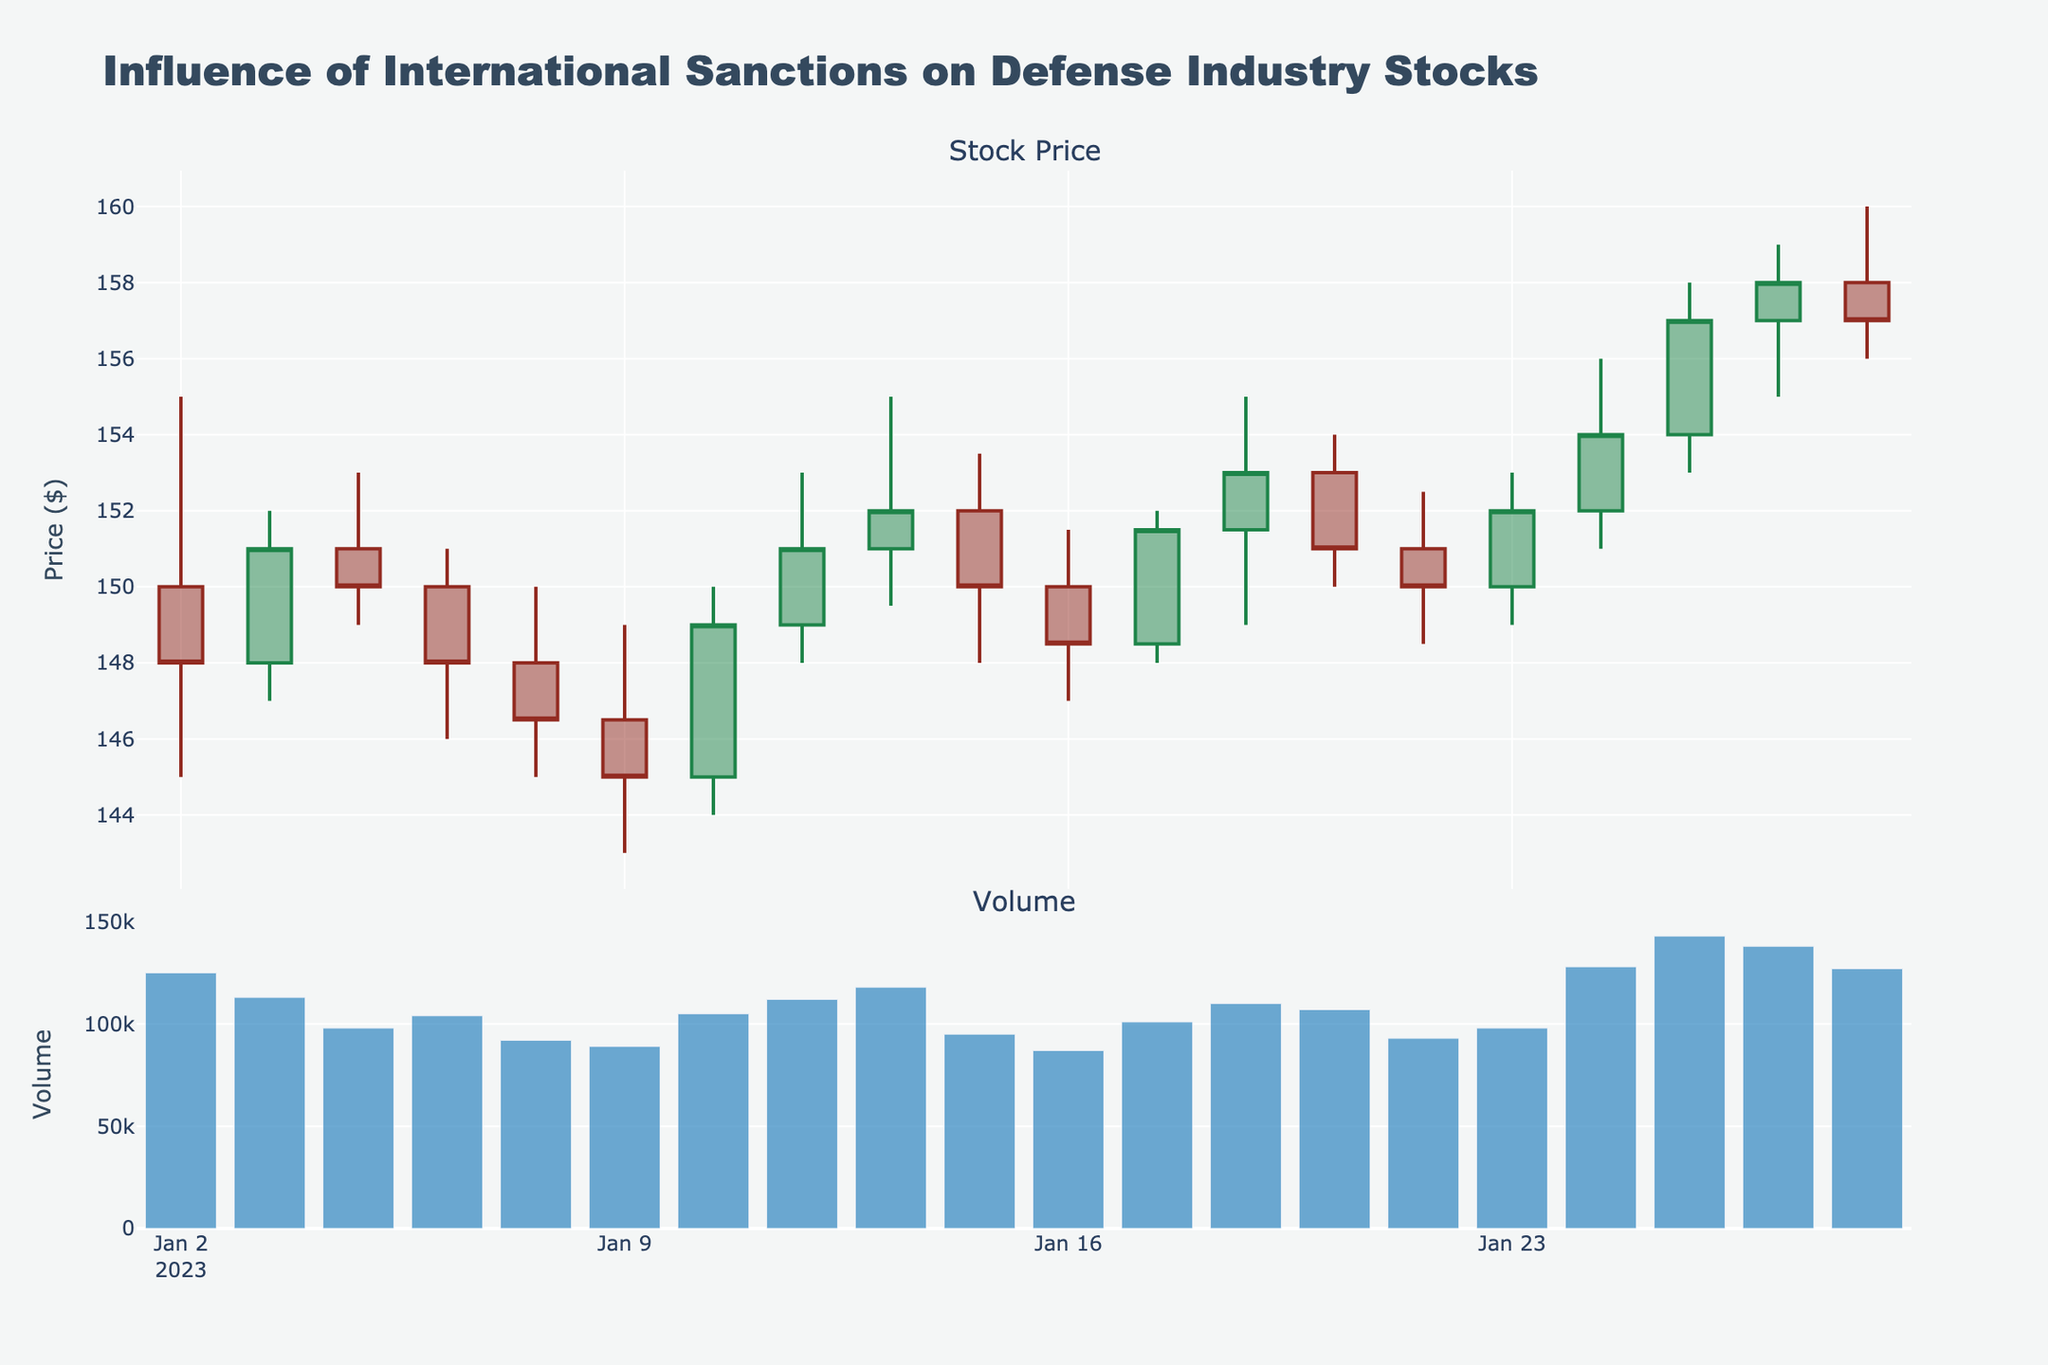What is the title of the plot? The title appears at the top of the plot and reads "Influence of International Sanctions on Defense Industry Stocks."
Answer: Influence of International Sanctions on Defense Industry Stocks What is the price range for the stock on January 2, 2023? On January 2, 2023, the candlestick shows a high of $155 and a low of $145.
Answer: $145 to $155 On which date does the stock volume peak? The volume bar chart at the bottom shows the highest peak on January 25, 2023.
Answer: January 25, 2023 What was the closing price on January 24, 2023? The candlestick indicates the closing price as the top part colored green on January 24, 2023, which is $154.
Answer: $154 How did the stock price trend between January 20 and January 25, 2023? Reviewing the candlestick plot, the stock price shows an increasing trend from $150 on January 20 to $157 on January 25.
Answer: Increasing trend How does the volume of January 9, 2023, compare to January 10, 2023? The volume on January 9 is 89,000 while on January 10, it is 105,000, showing an increase.
Answer: Volume increased Which date had the highest closing price in the data? The candlestick's uppermost part shows the highest closing price at $158 on January 26, 2023.
Answer: January 26, 2023 What can be inferred about the stock price behavior on January 12, 2023? The stock had a high volatility, with a high of $155, low of $149.50 and closed near its high at $152.
Answer: High volatility, closing near its high Calculate the average closing price for all the dates provided. Sum all closing prices ($148.00 + $151.00 + $150.00 + $148.00 + $146.50 + $145.00 + $149.00 + $151.00 + $152.00 + $150.00 + $148.50 + $151.50 + $153.00 + $151.00 + $150.00 + $152.00 + $154.00 + $157.00 + $158.00 + $157.00) = $3003, divide by 20 dates.
Answer: $150.15 Between January 16 and January 20, 2023, on which date did the stock close at its lowest, and what was the price? Comparing closing prices, January 16 had the lowest closing price at $148.50.
Answer: January 16, $148.50 